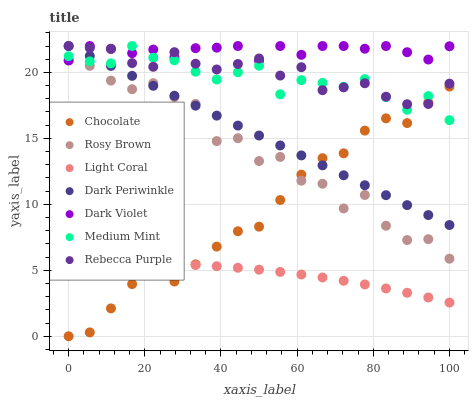Does Light Coral have the minimum area under the curve?
Answer yes or no. Yes. Does Dark Violet have the maximum area under the curve?
Answer yes or no. Yes. Does Rosy Brown have the minimum area under the curve?
Answer yes or no. No. Does Rosy Brown have the maximum area under the curve?
Answer yes or no. No. Is Dark Periwinkle the smoothest?
Answer yes or no. Yes. Is Rosy Brown the roughest?
Answer yes or no. Yes. Is Dark Violet the smoothest?
Answer yes or no. No. Is Dark Violet the roughest?
Answer yes or no. No. Does Chocolate have the lowest value?
Answer yes or no. Yes. Does Rosy Brown have the lowest value?
Answer yes or no. No. Does Dark Periwinkle have the highest value?
Answer yes or no. Yes. Does Rosy Brown have the highest value?
Answer yes or no. No. Is Rosy Brown less than Medium Mint?
Answer yes or no. Yes. Is Dark Violet greater than Chocolate?
Answer yes or no. Yes. Does Rosy Brown intersect Dark Periwinkle?
Answer yes or no. Yes. Is Rosy Brown less than Dark Periwinkle?
Answer yes or no. No. Is Rosy Brown greater than Dark Periwinkle?
Answer yes or no. No. Does Rosy Brown intersect Medium Mint?
Answer yes or no. No. 